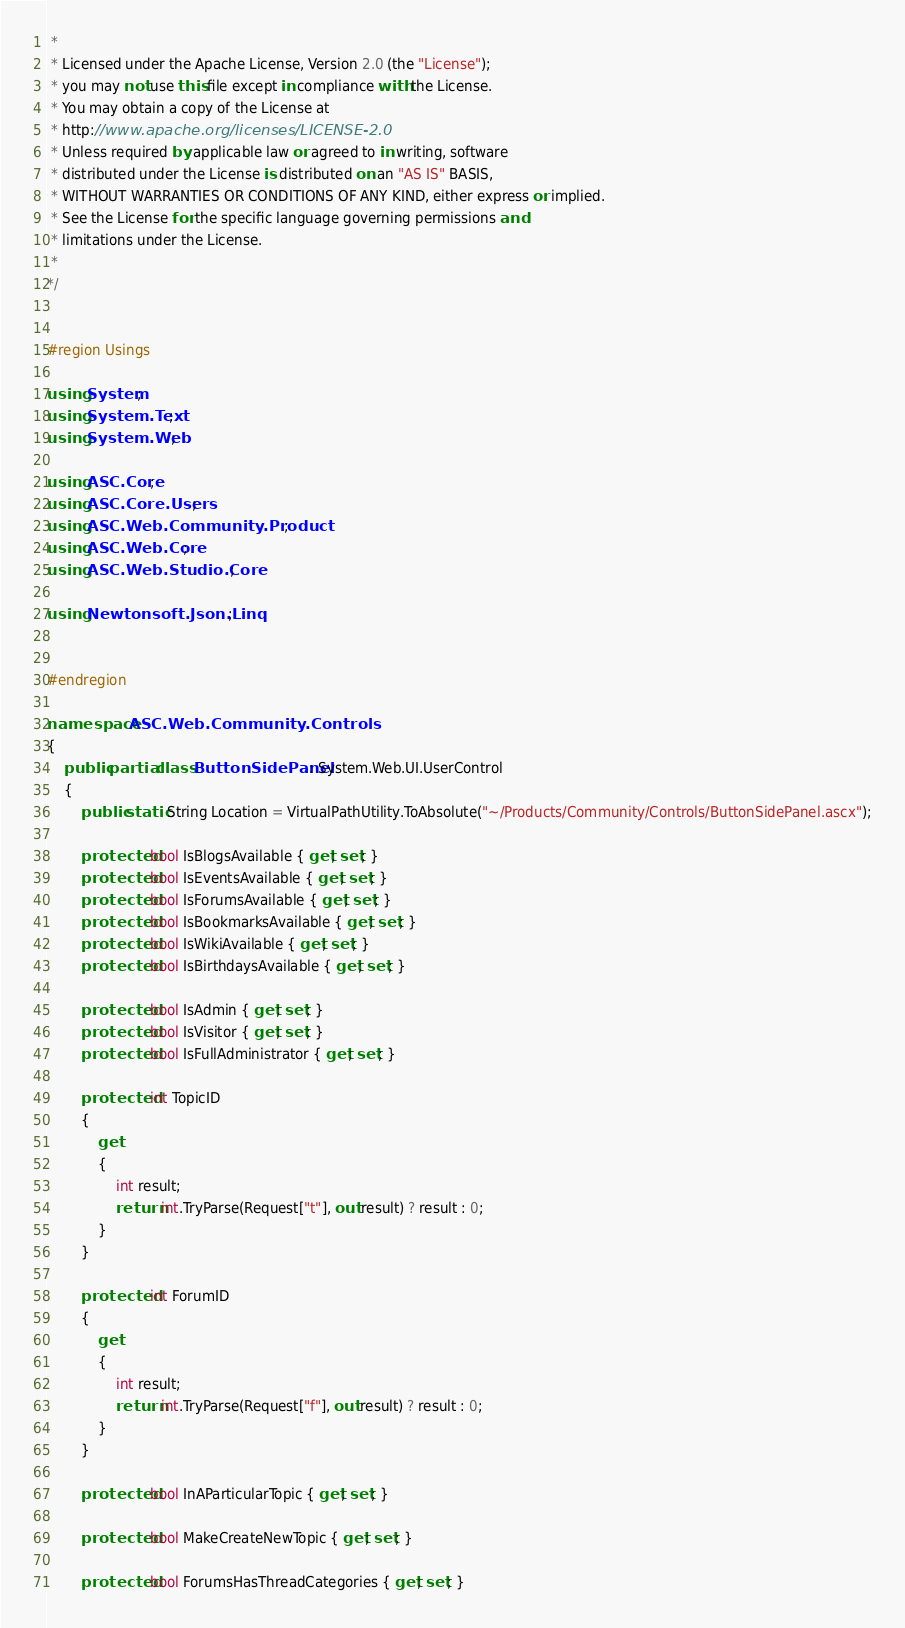<code> <loc_0><loc_0><loc_500><loc_500><_C#_> * 
 * Licensed under the Apache License, Version 2.0 (the "License");
 * you may not use this file except in compliance with the License.
 * You may obtain a copy of the License at
 * http://www.apache.org/licenses/LICENSE-2.0
 * Unless required by applicable law or agreed to in writing, software
 * distributed under the License is distributed on an "AS IS" BASIS,
 * WITHOUT WARRANTIES OR CONDITIONS OF ANY KIND, either express or implied.
 * See the License for the specific language governing permissions and
 * limitations under the License.
 *
*/


#region Usings

using System;
using System.Text;
using System.Web;

using ASC.Core;
using ASC.Core.Users;
using ASC.Web.Community.Product;
using ASC.Web.Core;
using ASC.Web.Studio.Core;

using Newtonsoft.Json.Linq;


#endregion

namespace ASC.Web.Community.Controls
{
    public partial class ButtonSidePanel : System.Web.UI.UserControl
    {
        public static String Location = VirtualPathUtility.ToAbsolute("~/Products/Community/Controls/ButtonSidePanel.ascx");

        protected bool IsBlogsAvailable { get; set; }
        protected bool IsEventsAvailable { get; set; }
        protected bool IsForumsAvailable { get; set; }
        protected bool IsBookmarksAvailable { get; set; }
        protected bool IsWikiAvailable { get; set; }
        protected bool IsBirthdaysAvailable { get; set; }

        protected bool IsAdmin { get; set; }
        protected bool IsVisitor { get; set; }
        protected bool IsFullAdministrator { get; set; }

        protected int TopicID
        {
            get
            {
                int result;
                return int.TryParse(Request["t"], out result) ? result : 0;
            }
        }

        protected int ForumID
        {
            get
            {
                int result;
                return int.TryParse(Request["f"], out result) ? result : 0;
            }
        }

        protected bool InAParticularTopic { get; set; }

        protected bool MakeCreateNewTopic { get; set; }

        protected bool ForumsHasThreadCategories { get; set; }
</code> 